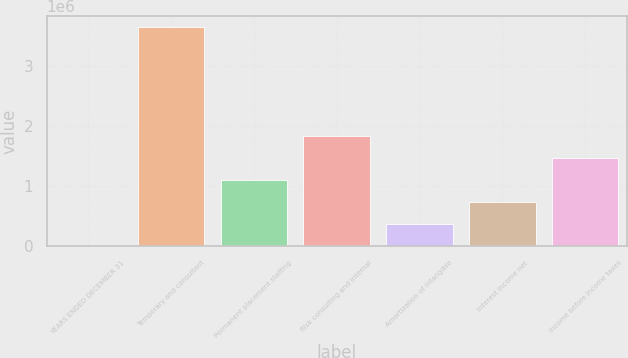Convert chart. <chart><loc_0><loc_0><loc_500><loc_500><bar_chart><fcel>YEARS ENDED DECEMBER 31<fcel>Temporary and consultant<fcel>Permanent placement staffing<fcel>Risk consulting and internal<fcel>Amortization of intangible<fcel>Interest income net<fcel>Income before income taxes<nl><fcel>2007<fcel>3.64927e+06<fcel>1.09619e+06<fcel>1.82564e+06<fcel>366734<fcel>731460<fcel>1.46091e+06<nl></chart> 